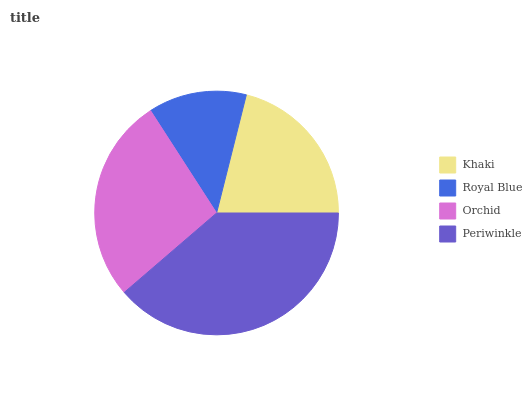Is Royal Blue the minimum?
Answer yes or no. Yes. Is Periwinkle the maximum?
Answer yes or no. Yes. Is Orchid the minimum?
Answer yes or no. No. Is Orchid the maximum?
Answer yes or no. No. Is Orchid greater than Royal Blue?
Answer yes or no. Yes. Is Royal Blue less than Orchid?
Answer yes or no. Yes. Is Royal Blue greater than Orchid?
Answer yes or no. No. Is Orchid less than Royal Blue?
Answer yes or no. No. Is Orchid the high median?
Answer yes or no. Yes. Is Khaki the low median?
Answer yes or no. Yes. Is Periwinkle the high median?
Answer yes or no. No. Is Periwinkle the low median?
Answer yes or no. No. 